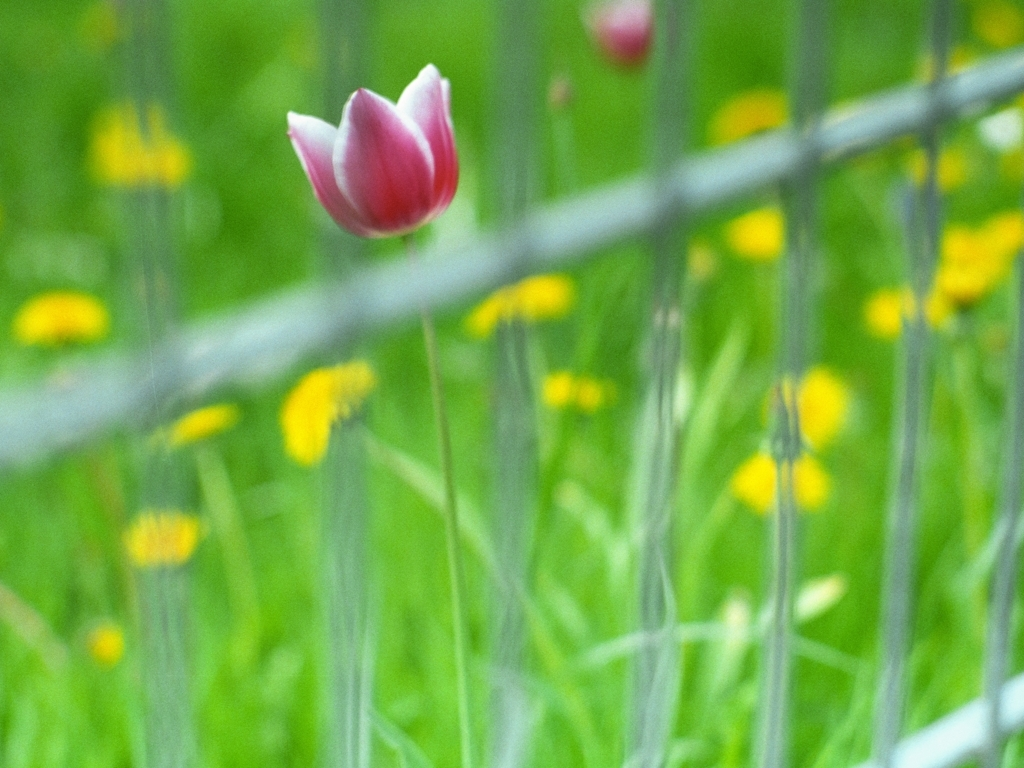Is there any blurriness in the picture? The photo does exhibit some blurriness, particularly towards the edges. The center of the image, focused on a tulip, appears sharper than the surrounding foliage and the wire fence, both of which display mild blurring likely due to the depth of field that emphasizes the flower as the subject. 